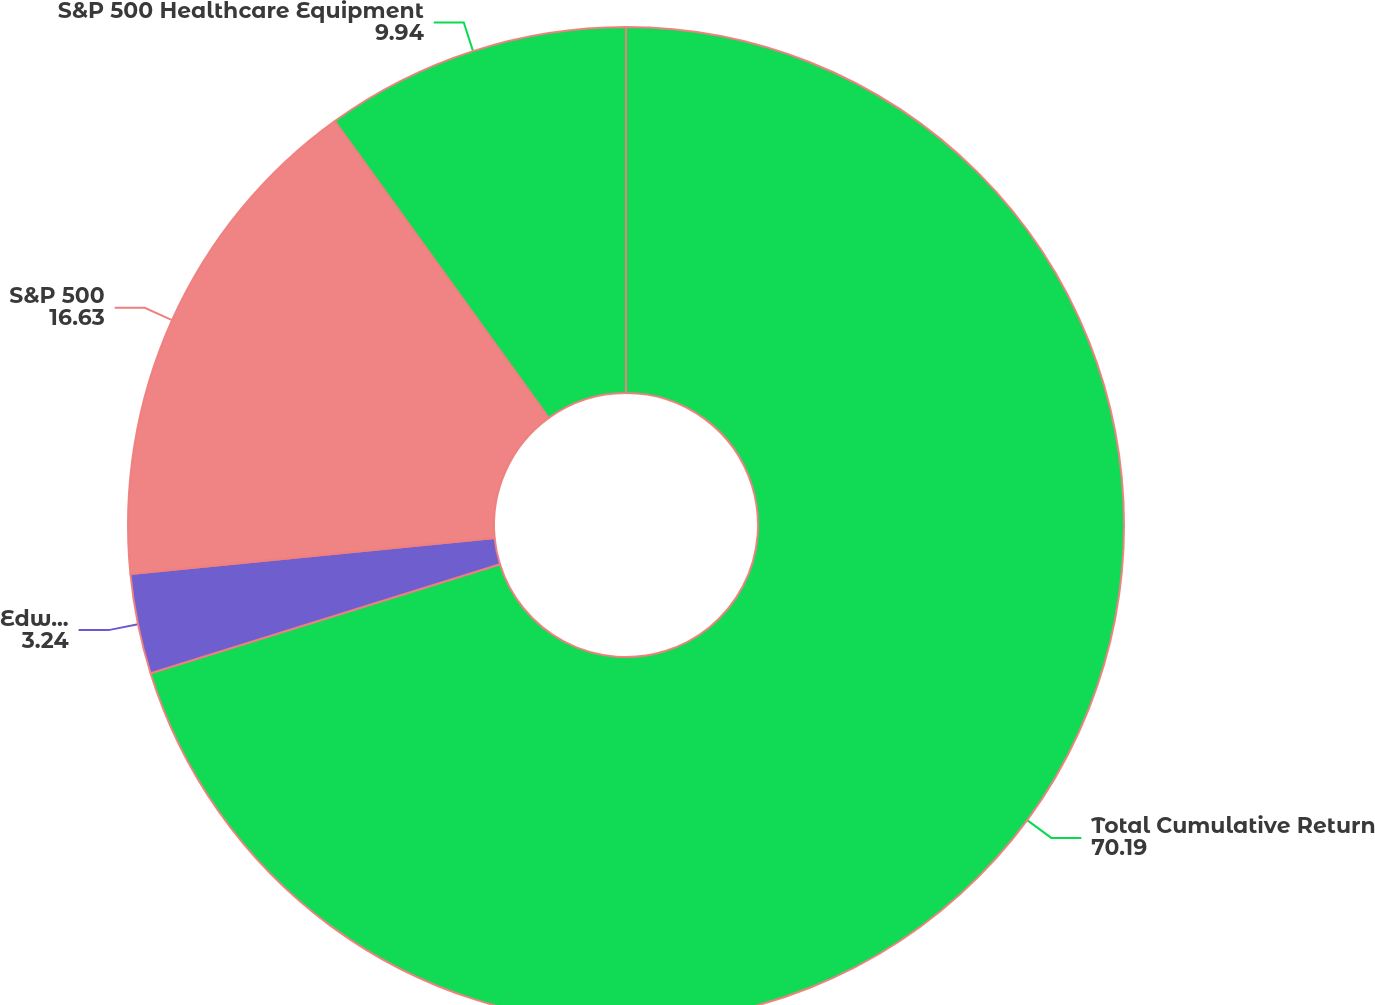<chart> <loc_0><loc_0><loc_500><loc_500><pie_chart><fcel>Total Cumulative Return<fcel>Edwards Lifesciences<fcel>S&P 500<fcel>S&P 500 Healthcare Equipment<nl><fcel>70.19%<fcel>3.24%<fcel>16.63%<fcel>9.94%<nl></chart> 